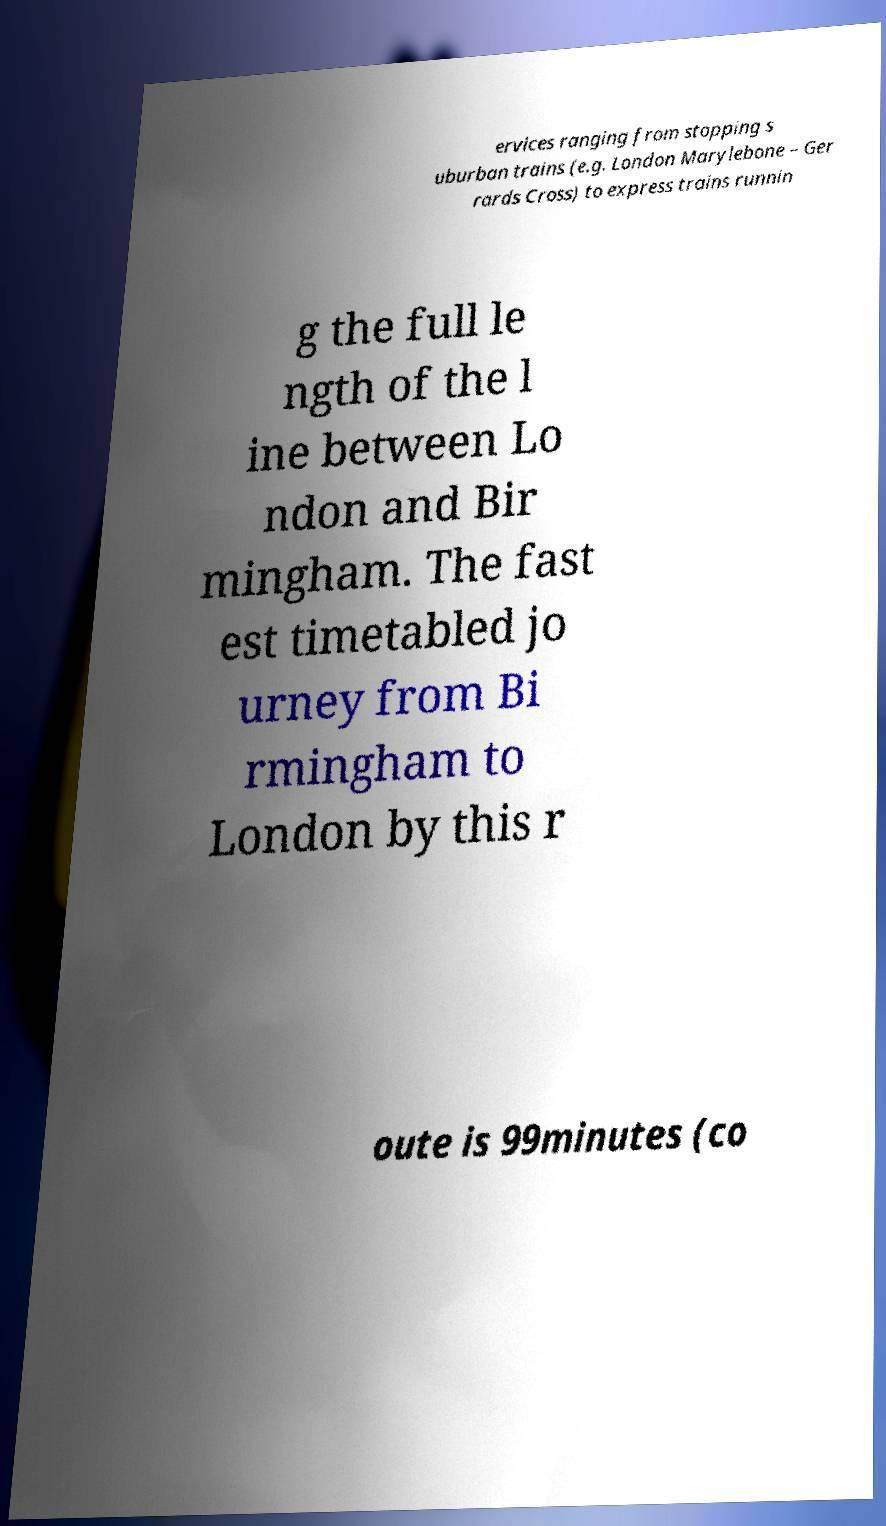For documentation purposes, I need the text within this image transcribed. Could you provide that? ervices ranging from stopping s uburban trains (e.g. London Marylebone – Ger rards Cross) to express trains runnin g the full le ngth of the l ine between Lo ndon and Bir mingham. The fast est timetabled jo urney from Bi rmingham to London by this r oute is 99minutes (co 